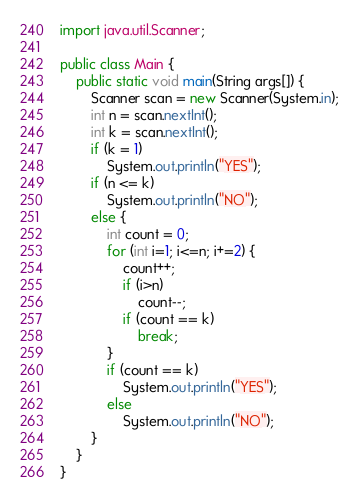Convert code to text. <code><loc_0><loc_0><loc_500><loc_500><_Java_>import java.util.Scanner;

public class Main {
    public static void main(String args[]) {
        Scanner scan = new Scanner(System.in);
        int n = scan.nextInt();
        int k = scan.nextInt();
        if (k = 1)
            System.out.println("YES");
        if (n <= k)
            System.out.println("NO");
        else {
            int count = 0;
            for (int i=1; i<=n; i+=2) {
                count++;
                if (i>n)
                    count--;
                if (count == k)
                    break;
            }
            if (count == k)
                System.out.println("YES");
            else
                System.out.println("NO");
        }
    }
}
</code> 